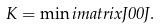Convert formula to latex. <formula><loc_0><loc_0><loc_500><loc_500>K = \min i m a t r i x { J } { 0 } { 0 } { J } .</formula> 